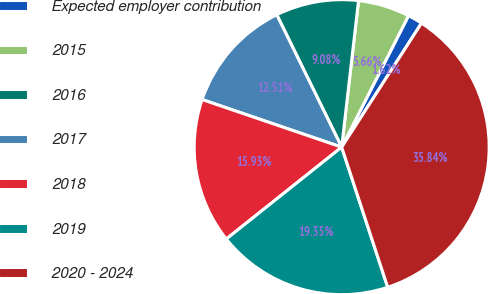<chart> <loc_0><loc_0><loc_500><loc_500><pie_chart><fcel>Expected employer contribution<fcel>2015<fcel>2016<fcel>2017<fcel>2018<fcel>2019<fcel>2020 - 2024<nl><fcel>1.62%<fcel>5.66%<fcel>9.08%<fcel>12.51%<fcel>15.93%<fcel>19.35%<fcel>35.84%<nl></chart> 